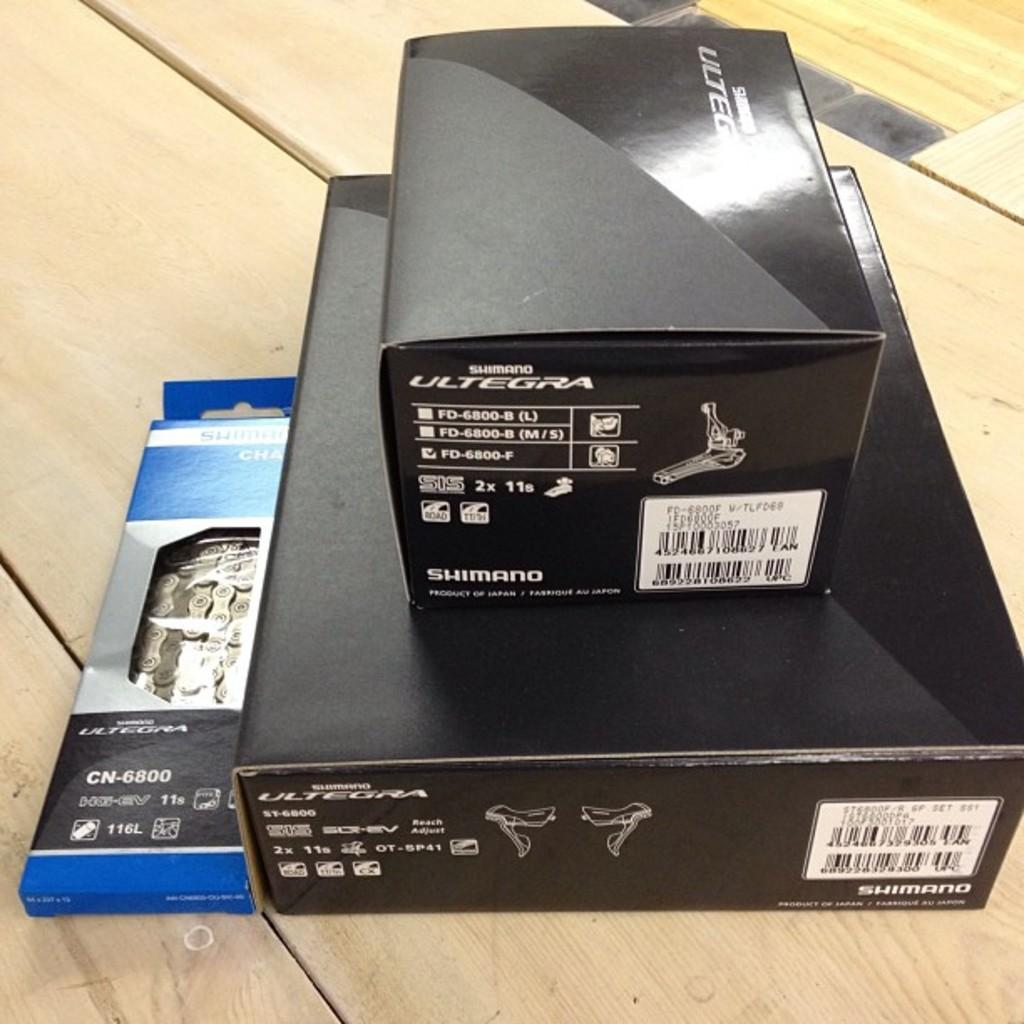Provide a one-sentence caption for the provided image. A pile of Shimano bike parts sits on a wooden surface. 